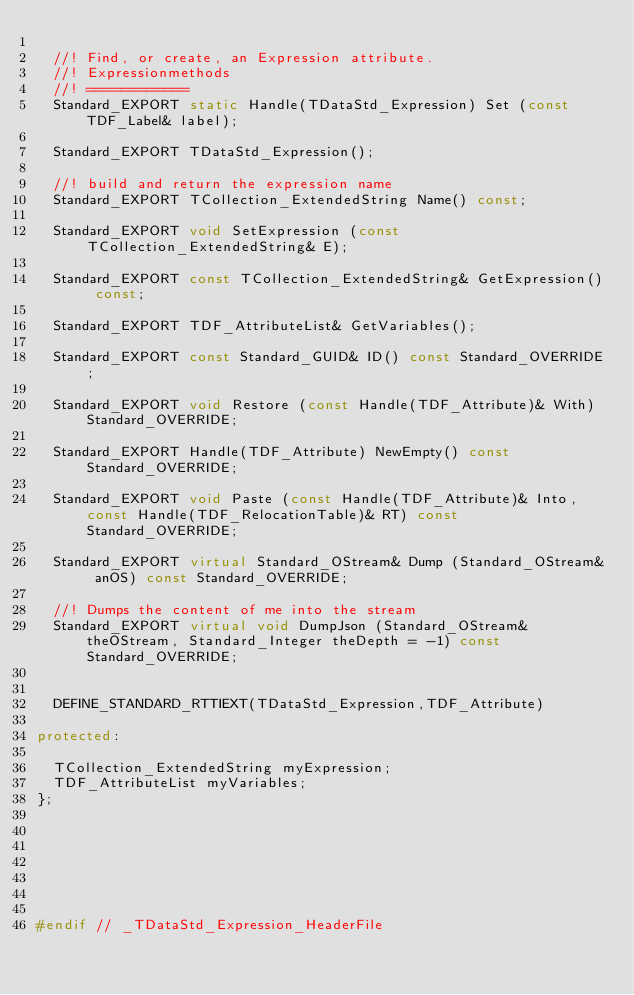<code> <loc_0><loc_0><loc_500><loc_500><_C++_>  
  //! Find, or create, an Expression attribute.
  //! Expressionmethods
  //! ============
  Standard_EXPORT static Handle(TDataStd_Expression) Set (const TDF_Label& label);
  
  Standard_EXPORT TDataStd_Expression();
  
  //! build and return the expression name
  Standard_EXPORT TCollection_ExtendedString Name() const;
  
  Standard_EXPORT void SetExpression (const TCollection_ExtendedString& E);
  
  Standard_EXPORT const TCollection_ExtendedString& GetExpression() const;
  
  Standard_EXPORT TDF_AttributeList& GetVariables();
  
  Standard_EXPORT const Standard_GUID& ID() const Standard_OVERRIDE;
  
  Standard_EXPORT void Restore (const Handle(TDF_Attribute)& With) Standard_OVERRIDE;
  
  Standard_EXPORT Handle(TDF_Attribute) NewEmpty() const Standard_OVERRIDE;
  
  Standard_EXPORT void Paste (const Handle(TDF_Attribute)& Into, const Handle(TDF_RelocationTable)& RT) const Standard_OVERRIDE;
  
  Standard_EXPORT virtual Standard_OStream& Dump (Standard_OStream& anOS) const Standard_OVERRIDE;
  
  //! Dumps the content of me into the stream
  Standard_EXPORT virtual void DumpJson (Standard_OStream& theOStream, Standard_Integer theDepth = -1) const Standard_OVERRIDE;


  DEFINE_STANDARD_RTTIEXT(TDataStd_Expression,TDF_Attribute)

protected:

  TCollection_ExtendedString myExpression;
  TDF_AttributeList myVariables;
};







#endif // _TDataStd_Expression_HeaderFile
</code> 